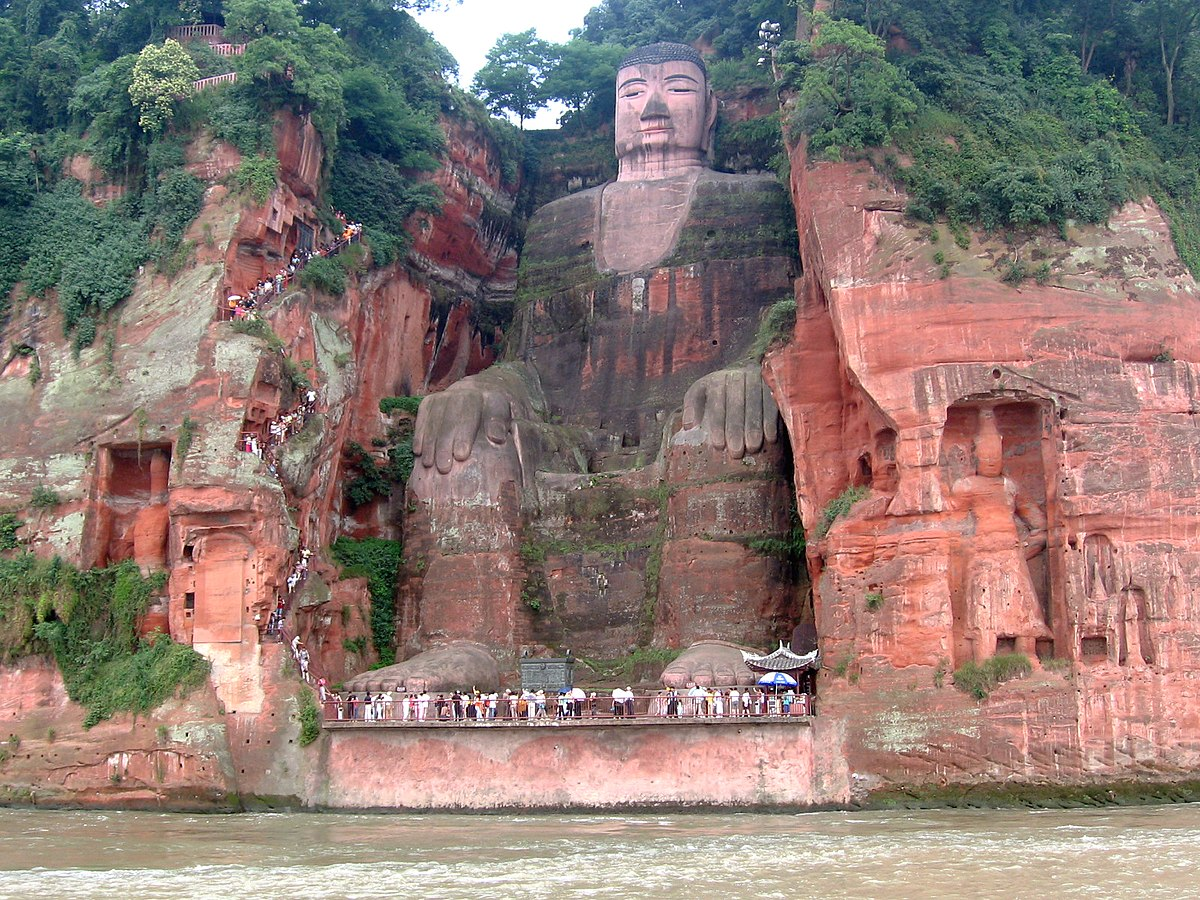What artistic techniques were employed in the creation of the Leshan Giant Buddha? The artisans used sophisticated techniques to carve the Leshan Giant Buddha directly from the red sandstone cliff, reflecting the high craftsmanship of the Tang Dynasty. Techniques included detailed chiseling for precise facial expressions and drapery of robes, and larger, rougher cuts for the overall shape. A notable engineering technique was the system of hidden gutters and channels throughout the hair, behind the head and in the folds of the robes, which serve as drainage systems to protect the statue from erosion caused by rainwater. 